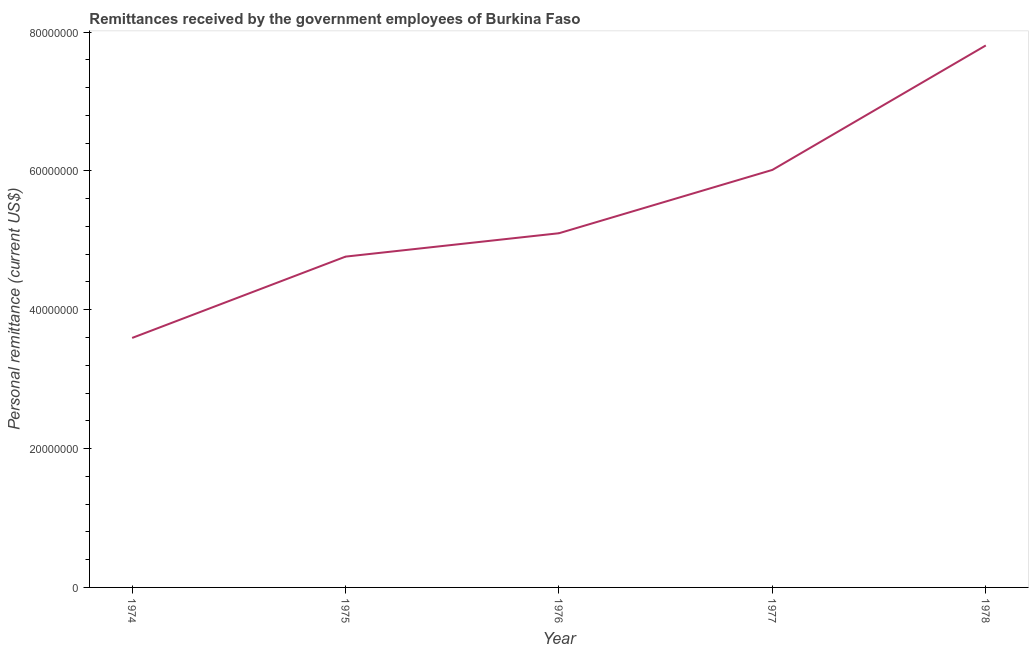What is the personal remittances in 1976?
Your answer should be very brief. 5.10e+07. Across all years, what is the maximum personal remittances?
Provide a succinct answer. 7.81e+07. Across all years, what is the minimum personal remittances?
Offer a very short reply. 3.59e+07. In which year was the personal remittances maximum?
Keep it short and to the point. 1978. In which year was the personal remittances minimum?
Offer a very short reply. 1974. What is the sum of the personal remittances?
Your answer should be compact. 2.73e+08. What is the difference between the personal remittances in 1974 and 1978?
Offer a terse response. -4.21e+07. What is the average personal remittances per year?
Offer a terse response. 5.46e+07. What is the median personal remittances?
Offer a terse response. 5.10e+07. In how many years, is the personal remittances greater than 16000000 US$?
Provide a succinct answer. 5. What is the ratio of the personal remittances in 1974 to that in 1976?
Provide a succinct answer. 0.7. Is the difference between the personal remittances in 1975 and 1977 greater than the difference between any two years?
Provide a succinct answer. No. What is the difference between the highest and the second highest personal remittances?
Keep it short and to the point. 1.79e+07. What is the difference between the highest and the lowest personal remittances?
Make the answer very short. 4.21e+07. In how many years, is the personal remittances greater than the average personal remittances taken over all years?
Your answer should be compact. 2. Does the personal remittances monotonically increase over the years?
Offer a very short reply. Yes. Does the graph contain any zero values?
Your answer should be compact. No. What is the title of the graph?
Provide a short and direct response. Remittances received by the government employees of Burkina Faso. What is the label or title of the Y-axis?
Keep it short and to the point. Personal remittance (current US$). What is the Personal remittance (current US$) of 1974?
Provide a succinct answer. 3.59e+07. What is the Personal remittance (current US$) of 1975?
Provide a succinct answer. 4.77e+07. What is the Personal remittance (current US$) of 1976?
Provide a succinct answer. 5.10e+07. What is the Personal remittance (current US$) in 1977?
Offer a terse response. 6.01e+07. What is the Personal remittance (current US$) of 1978?
Give a very brief answer. 7.81e+07. What is the difference between the Personal remittance (current US$) in 1974 and 1975?
Give a very brief answer. -1.17e+07. What is the difference between the Personal remittance (current US$) in 1974 and 1976?
Your answer should be compact. -1.51e+07. What is the difference between the Personal remittance (current US$) in 1974 and 1977?
Give a very brief answer. -2.42e+07. What is the difference between the Personal remittance (current US$) in 1974 and 1978?
Keep it short and to the point. -4.21e+07. What is the difference between the Personal remittance (current US$) in 1975 and 1976?
Provide a succinct answer. -3.37e+06. What is the difference between the Personal remittance (current US$) in 1975 and 1977?
Your response must be concise. -1.25e+07. What is the difference between the Personal remittance (current US$) in 1975 and 1978?
Provide a succinct answer. -3.04e+07. What is the difference between the Personal remittance (current US$) in 1976 and 1977?
Ensure brevity in your answer.  -9.12e+06. What is the difference between the Personal remittance (current US$) in 1976 and 1978?
Your answer should be compact. -2.71e+07. What is the difference between the Personal remittance (current US$) in 1977 and 1978?
Provide a short and direct response. -1.79e+07. What is the ratio of the Personal remittance (current US$) in 1974 to that in 1975?
Provide a succinct answer. 0.75. What is the ratio of the Personal remittance (current US$) in 1974 to that in 1976?
Your answer should be compact. 0.7. What is the ratio of the Personal remittance (current US$) in 1974 to that in 1977?
Your answer should be very brief. 0.6. What is the ratio of the Personal remittance (current US$) in 1974 to that in 1978?
Your answer should be compact. 0.46. What is the ratio of the Personal remittance (current US$) in 1975 to that in 1976?
Keep it short and to the point. 0.93. What is the ratio of the Personal remittance (current US$) in 1975 to that in 1977?
Make the answer very short. 0.79. What is the ratio of the Personal remittance (current US$) in 1975 to that in 1978?
Your answer should be very brief. 0.61. What is the ratio of the Personal remittance (current US$) in 1976 to that in 1977?
Provide a short and direct response. 0.85. What is the ratio of the Personal remittance (current US$) in 1976 to that in 1978?
Ensure brevity in your answer.  0.65. What is the ratio of the Personal remittance (current US$) in 1977 to that in 1978?
Give a very brief answer. 0.77. 